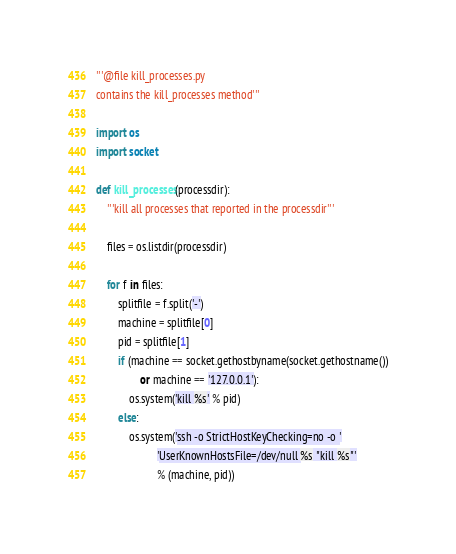Convert code to text. <code><loc_0><loc_0><loc_500><loc_500><_Python_>'''@file kill_processes.py
contains the kill_processes method'''

import os
import socket

def kill_processes(processdir):
    '''kill all processes that reported in the processdir'''

    files = os.listdir(processdir)

    for f in files:
        splitfile = f.split('-')
        machine = splitfile[0]
        pid = splitfile[1]
        if (machine == socket.gethostbyname(socket.gethostname())
                or machine == '127.0.0.1'):
            os.system('kill %s' % pid)
        else:
            os.system('ssh -o StrictHostKeyChecking=no -o '
                      'UserKnownHostsFile=/dev/null %s "kill %s"'
                      % (machine, pid))
</code> 